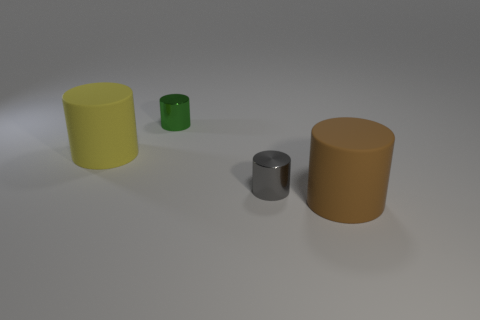How many other things are the same size as the brown rubber object?
Provide a short and direct response. 1. Are there any matte cylinders that have the same size as the brown thing?
Provide a succinct answer. Yes. What number of objects are blocks or green metallic cylinders?
Your response must be concise. 1. Does the metallic cylinder in front of the yellow cylinder have the same size as the large brown rubber cylinder?
Ensure brevity in your answer.  No. There is a thing that is right of the yellow rubber thing and behind the tiny gray cylinder; how big is it?
Ensure brevity in your answer.  Small. How many other objects are the same shape as the brown object?
Provide a short and direct response. 3. What size is the brown matte thing that is the same shape as the yellow rubber object?
Provide a short and direct response. Large. There is a cylinder that is both in front of the yellow thing and behind the big brown thing; what color is it?
Give a very brief answer. Gray. How many things are big brown matte things that are in front of the small green shiny cylinder or large purple metal cylinders?
Provide a short and direct response. 1. What is the color of the other big object that is the same shape as the brown matte thing?
Give a very brief answer. Yellow. 